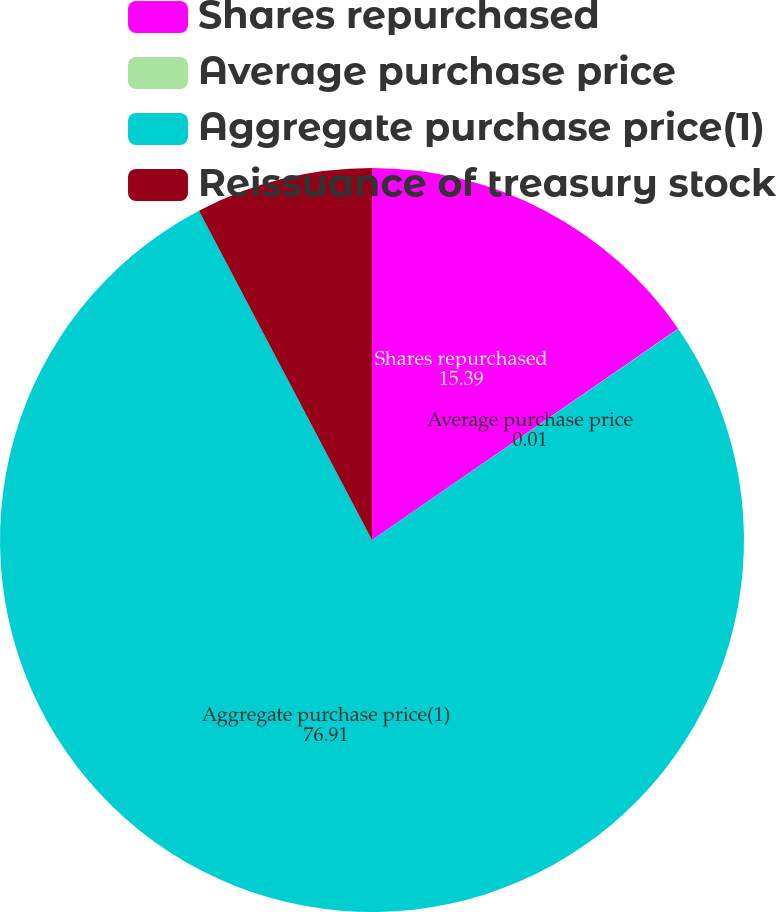Convert chart. <chart><loc_0><loc_0><loc_500><loc_500><pie_chart><fcel>Shares repurchased<fcel>Average purchase price<fcel>Aggregate purchase price(1)<fcel>Reissuance of treasury stock<nl><fcel>15.39%<fcel>0.01%<fcel>76.91%<fcel>7.7%<nl></chart> 